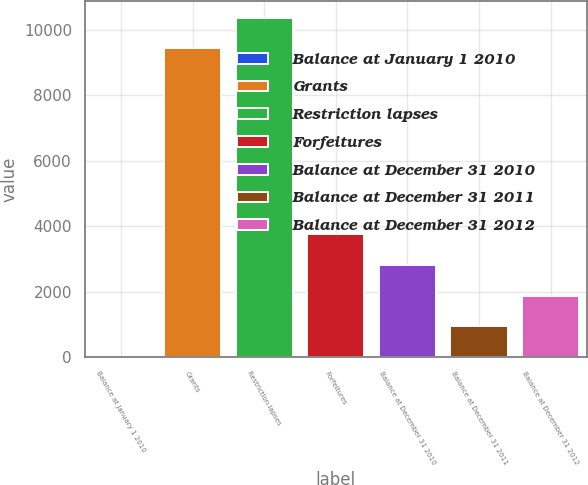Convert chart. <chart><loc_0><loc_0><loc_500><loc_500><bar_chart><fcel>Balance at January 1 2010<fcel>Grants<fcel>Restriction lapses<fcel>Forfeitures<fcel>Balance at December 31 2010<fcel>Balance at December 31 2011<fcel>Balance at December 31 2012<nl><fcel>0.26<fcel>9423<fcel>10365.3<fcel>3769.34<fcel>2827.07<fcel>942.53<fcel>1884.8<nl></chart> 